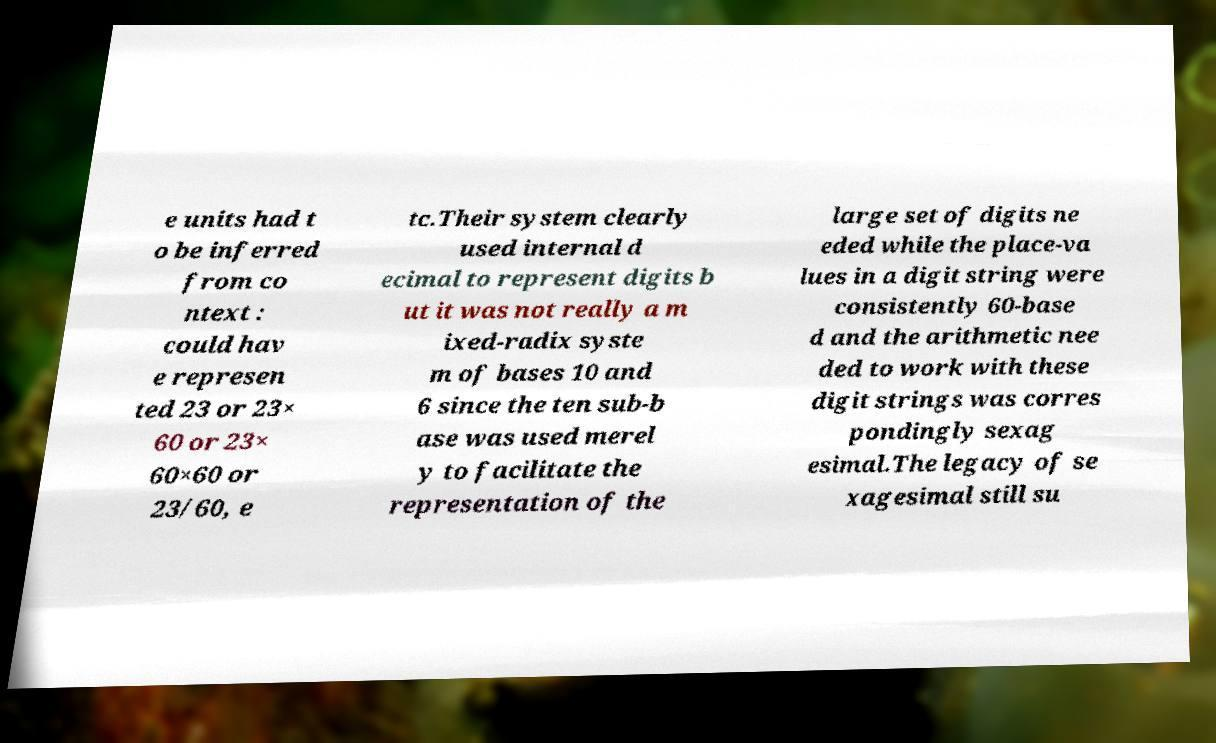Could you assist in decoding the text presented in this image and type it out clearly? e units had t o be inferred from co ntext : could hav e represen ted 23 or 23× 60 or 23× 60×60 or 23/60, e tc.Their system clearly used internal d ecimal to represent digits b ut it was not really a m ixed-radix syste m of bases 10 and 6 since the ten sub-b ase was used merel y to facilitate the representation of the large set of digits ne eded while the place-va lues in a digit string were consistently 60-base d and the arithmetic nee ded to work with these digit strings was corres pondingly sexag esimal.The legacy of se xagesimal still su 